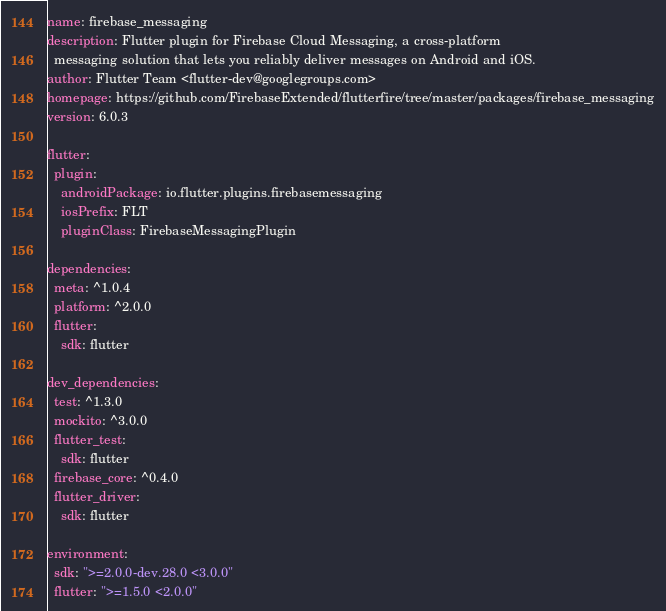<code> <loc_0><loc_0><loc_500><loc_500><_YAML_>name: firebase_messaging
description: Flutter plugin for Firebase Cloud Messaging, a cross-platform
  messaging solution that lets you reliably deliver messages on Android and iOS.
author: Flutter Team <flutter-dev@googlegroups.com>
homepage: https://github.com/FirebaseExtended/flutterfire/tree/master/packages/firebase_messaging
version: 6.0.3

flutter:
  plugin:
    androidPackage: io.flutter.plugins.firebasemessaging
    iosPrefix: FLT
    pluginClass: FirebaseMessagingPlugin

dependencies:
  meta: ^1.0.4
  platform: ^2.0.0
  flutter:
    sdk: flutter

dev_dependencies:
  test: ^1.3.0
  mockito: ^3.0.0
  flutter_test:
    sdk: flutter
  firebase_core: ^0.4.0
  flutter_driver:
    sdk: flutter

environment:
  sdk: ">=2.0.0-dev.28.0 <3.0.0"
  flutter: ">=1.5.0 <2.0.0"
</code> 